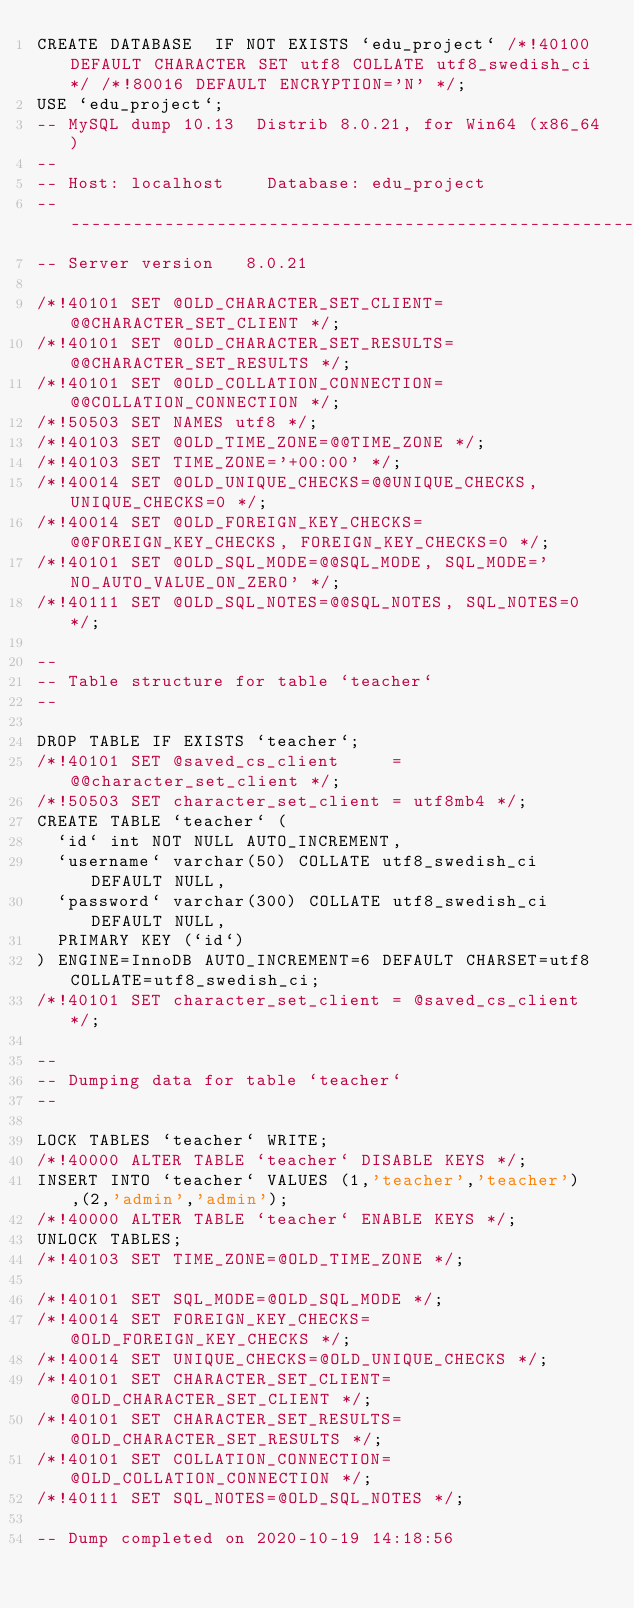<code> <loc_0><loc_0><loc_500><loc_500><_SQL_>CREATE DATABASE  IF NOT EXISTS `edu_project` /*!40100 DEFAULT CHARACTER SET utf8 COLLATE utf8_swedish_ci */ /*!80016 DEFAULT ENCRYPTION='N' */;
USE `edu_project`;
-- MySQL dump 10.13  Distrib 8.0.21, for Win64 (x86_64)
--
-- Host: localhost    Database: edu_project
-- ------------------------------------------------------
-- Server version	8.0.21

/*!40101 SET @OLD_CHARACTER_SET_CLIENT=@@CHARACTER_SET_CLIENT */;
/*!40101 SET @OLD_CHARACTER_SET_RESULTS=@@CHARACTER_SET_RESULTS */;
/*!40101 SET @OLD_COLLATION_CONNECTION=@@COLLATION_CONNECTION */;
/*!50503 SET NAMES utf8 */;
/*!40103 SET @OLD_TIME_ZONE=@@TIME_ZONE */;
/*!40103 SET TIME_ZONE='+00:00' */;
/*!40014 SET @OLD_UNIQUE_CHECKS=@@UNIQUE_CHECKS, UNIQUE_CHECKS=0 */;
/*!40014 SET @OLD_FOREIGN_KEY_CHECKS=@@FOREIGN_KEY_CHECKS, FOREIGN_KEY_CHECKS=0 */;
/*!40101 SET @OLD_SQL_MODE=@@SQL_MODE, SQL_MODE='NO_AUTO_VALUE_ON_ZERO' */;
/*!40111 SET @OLD_SQL_NOTES=@@SQL_NOTES, SQL_NOTES=0 */;

--
-- Table structure for table `teacher`
--

DROP TABLE IF EXISTS `teacher`;
/*!40101 SET @saved_cs_client     = @@character_set_client */;
/*!50503 SET character_set_client = utf8mb4 */;
CREATE TABLE `teacher` (
  `id` int NOT NULL AUTO_INCREMENT,
  `username` varchar(50) COLLATE utf8_swedish_ci DEFAULT NULL,
  `password` varchar(300) COLLATE utf8_swedish_ci DEFAULT NULL,
  PRIMARY KEY (`id`)
) ENGINE=InnoDB AUTO_INCREMENT=6 DEFAULT CHARSET=utf8 COLLATE=utf8_swedish_ci;
/*!40101 SET character_set_client = @saved_cs_client */;

--
-- Dumping data for table `teacher`
--

LOCK TABLES `teacher` WRITE;
/*!40000 ALTER TABLE `teacher` DISABLE KEYS */;
INSERT INTO `teacher` VALUES (1,'teacher','teacher'),(2,'admin','admin');
/*!40000 ALTER TABLE `teacher` ENABLE KEYS */;
UNLOCK TABLES;
/*!40103 SET TIME_ZONE=@OLD_TIME_ZONE */;

/*!40101 SET SQL_MODE=@OLD_SQL_MODE */;
/*!40014 SET FOREIGN_KEY_CHECKS=@OLD_FOREIGN_KEY_CHECKS */;
/*!40014 SET UNIQUE_CHECKS=@OLD_UNIQUE_CHECKS */;
/*!40101 SET CHARACTER_SET_CLIENT=@OLD_CHARACTER_SET_CLIENT */;
/*!40101 SET CHARACTER_SET_RESULTS=@OLD_CHARACTER_SET_RESULTS */;
/*!40101 SET COLLATION_CONNECTION=@OLD_COLLATION_CONNECTION */;
/*!40111 SET SQL_NOTES=@OLD_SQL_NOTES */;

-- Dump completed on 2020-10-19 14:18:56
</code> 